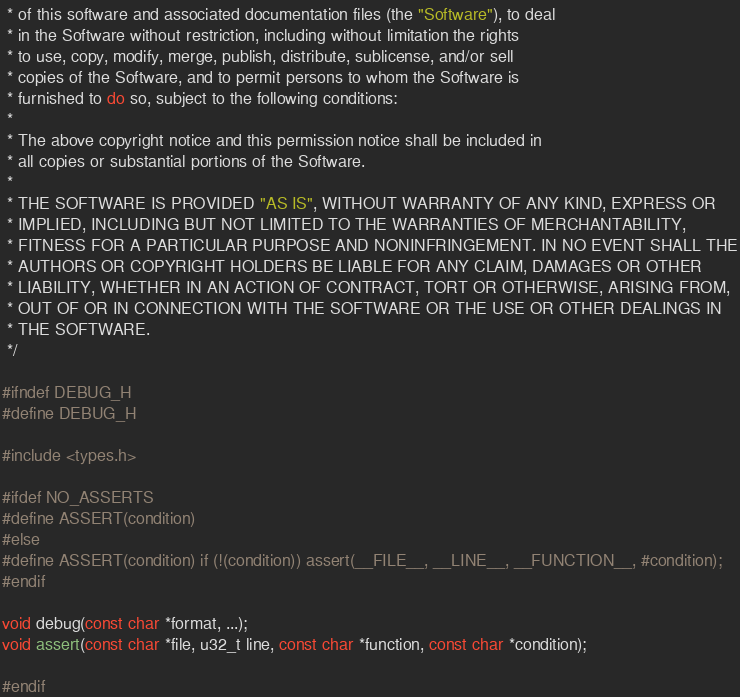<code> <loc_0><loc_0><loc_500><loc_500><_C_> * of this software and associated documentation files (the "Software"), to deal
 * in the Software without restriction, including without limitation the rights
 * to use, copy, modify, merge, publish, distribute, sublicense, and/or sell
 * copies of the Software, and to permit persons to whom the Software is
 * furnished to do so, subject to the following conditions:
 *
 * The above copyright notice and this permission notice shall be included in
 * all copies or substantial portions of the Software.
 *
 * THE SOFTWARE IS PROVIDED "AS IS", WITHOUT WARRANTY OF ANY KIND, EXPRESS OR
 * IMPLIED, INCLUDING BUT NOT LIMITED TO THE WARRANTIES OF MERCHANTABILITY,
 * FITNESS FOR A PARTICULAR PURPOSE AND NONINFRINGEMENT. IN NO EVENT SHALL THE
 * AUTHORS OR COPYRIGHT HOLDERS BE LIABLE FOR ANY CLAIM, DAMAGES OR OTHER
 * LIABILITY, WHETHER IN AN ACTION OF CONTRACT, TORT OR OTHERWISE, ARISING FROM,
 * OUT OF OR IN CONNECTION WITH THE SOFTWARE OR THE USE OR OTHER DEALINGS IN
 * THE SOFTWARE.
 */

#ifndef DEBUG_H
#define DEBUG_H

#include <types.h>

#ifdef NO_ASSERTS
#define ASSERT(condition)
#else
#define ASSERT(condition) if (!(condition)) assert(__FILE__, __LINE__, __FUNCTION__, #condition);
#endif

void debug(const char *format, ...);
void assert(const char *file, u32_t line, const char *function, const char *condition);

#endif
</code> 